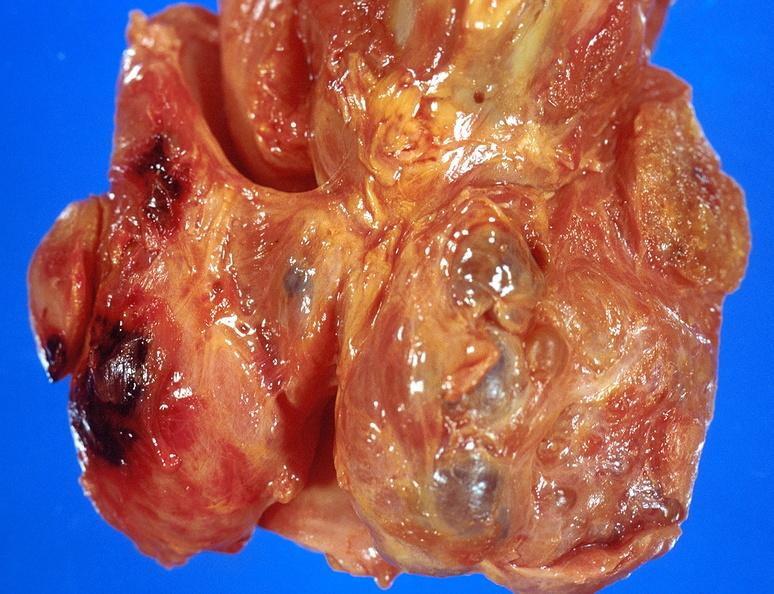s mesothelioma present?
Answer the question using a single word or phrase. No 